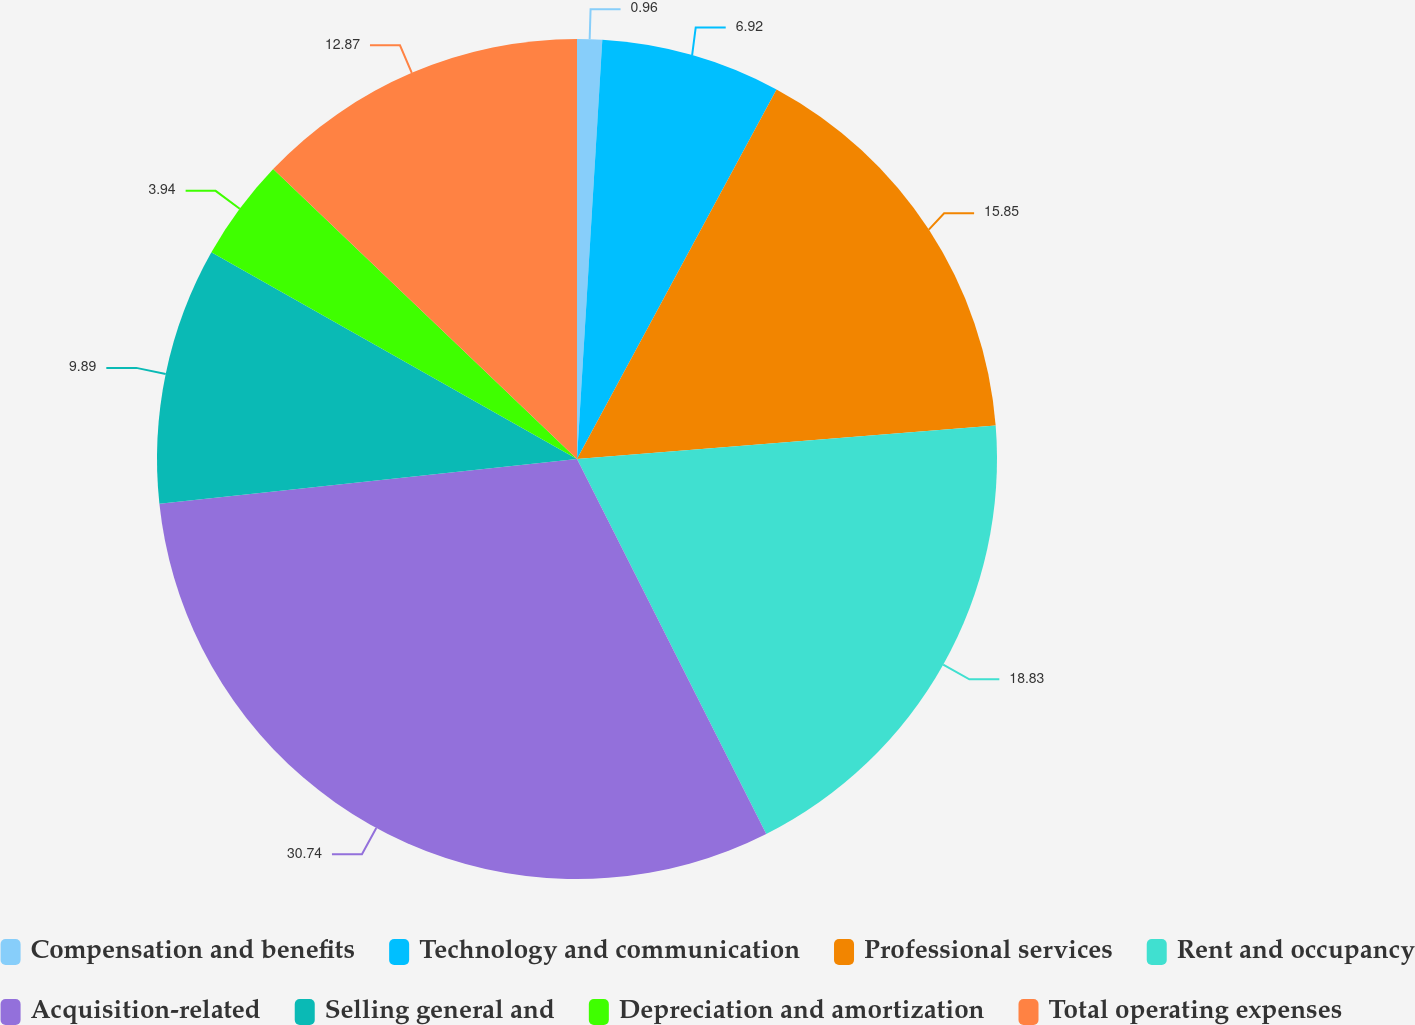<chart> <loc_0><loc_0><loc_500><loc_500><pie_chart><fcel>Compensation and benefits<fcel>Technology and communication<fcel>Professional services<fcel>Rent and occupancy<fcel>Acquisition-related<fcel>Selling general and<fcel>Depreciation and amortization<fcel>Total operating expenses<nl><fcel>0.96%<fcel>6.92%<fcel>15.85%<fcel>18.83%<fcel>30.74%<fcel>9.89%<fcel>3.94%<fcel>12.87%<nl></chart> 